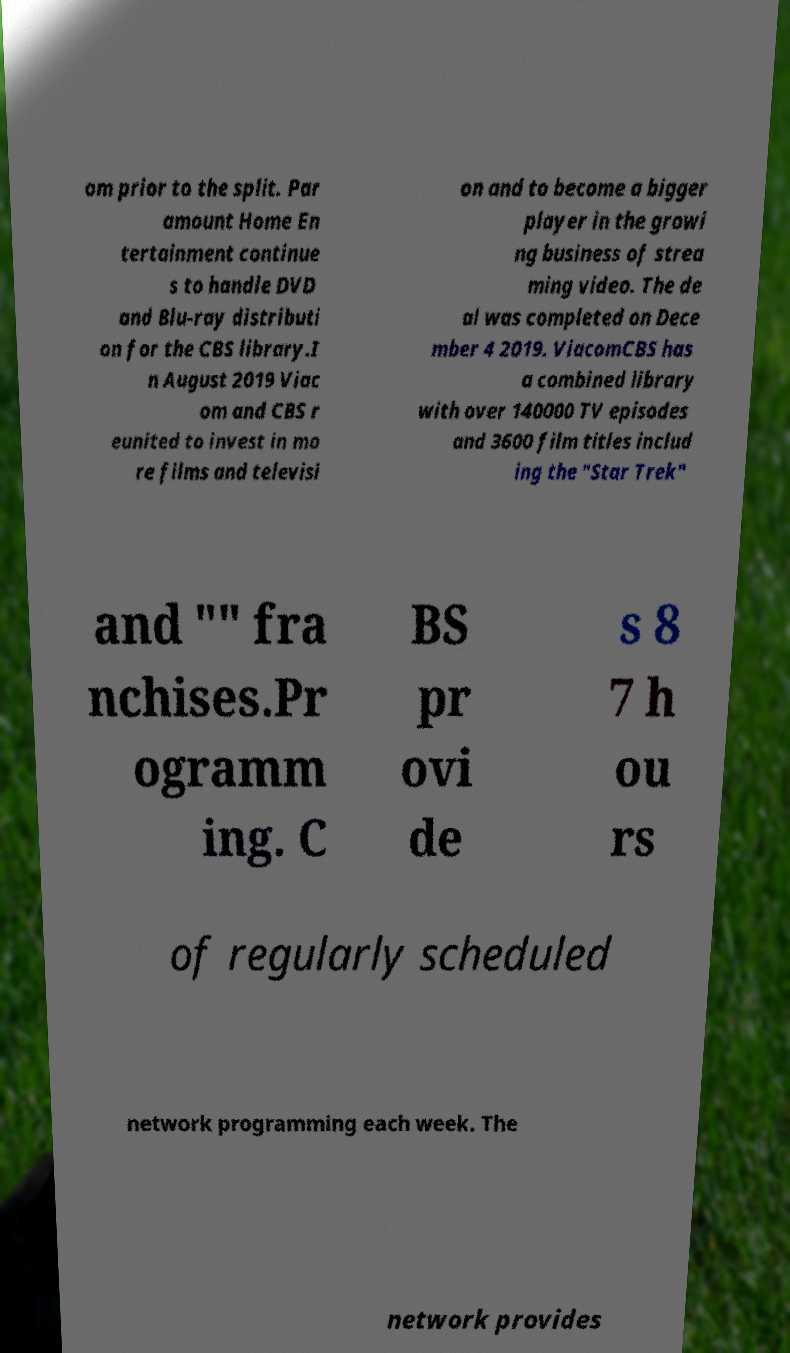Can you accurately transcribe the text from the provided image for me? om prior to the split. Par amount Home En tertainment continue s to handle DVD and Blu-ray distributi on for the CBS library.I n August 2019 Viac om and CBS r eunited to invest in mo re films and televisi on and to become a bigger player in the growi ng business of strea ming video. The de al was completed on Dece mber 4 2019. ViacomCBS has a combined library with over 140000 TV episodes and 3600 film titles includ ing the "Star Trek" and "" fra nchises.Pr ogramm ing. C BS pr ovi de s 8 7 h ou rs of regularly scheduled network programming each week. The network provides 